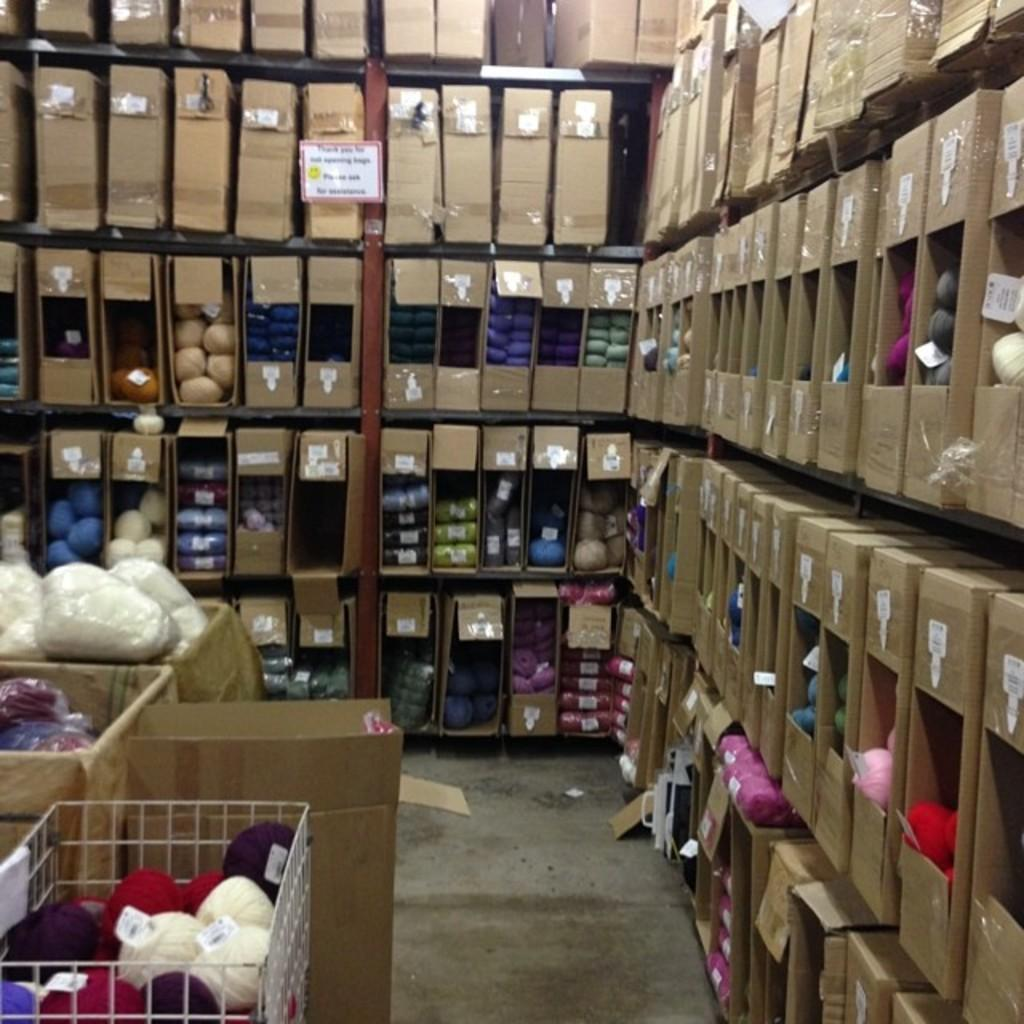What type of material is present in the image? There are woolen threads in the image. How do the woolen threads differ from each other? The woolen threads come in different types and colors. Where are the woolen threads located? The woolen threads are on shelves. What can be seen at the bottom of the image? There is a floor visible at the bottom of the image. What type of grain can be seen growing on the moon in the image? There is no grain or moon present in the image; it features woolen threads on shelves. 